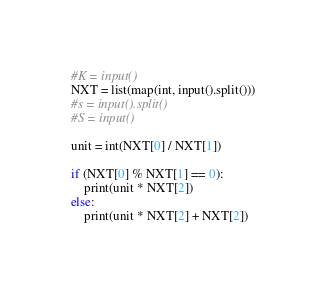Convert code to text. <code><loc_0><loc_0><loc_500><loc_500><_Python_>#K = input()
NXT = list(map(int, input().split()))
#s = input().split()
#S = input()

unit = int(NXT[0] / NXT[1])

if (NXT[0] % NXT[1] == 0):
    print(unit * NXT[2])
else:
    print(unit * NXT[2] + NXT[2])</code> 